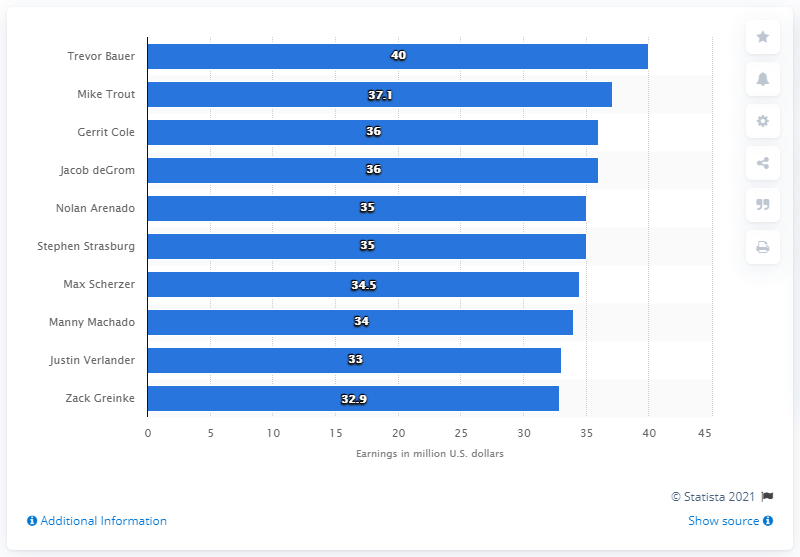Point out several critical features in this image. The second highest paid player in Major League Baseball was Mike Trout. Trevor Bauer's annual earnings were approximately $40 million. Trevor Bauer was the highest paid player in Major League Baseball during the given year. 